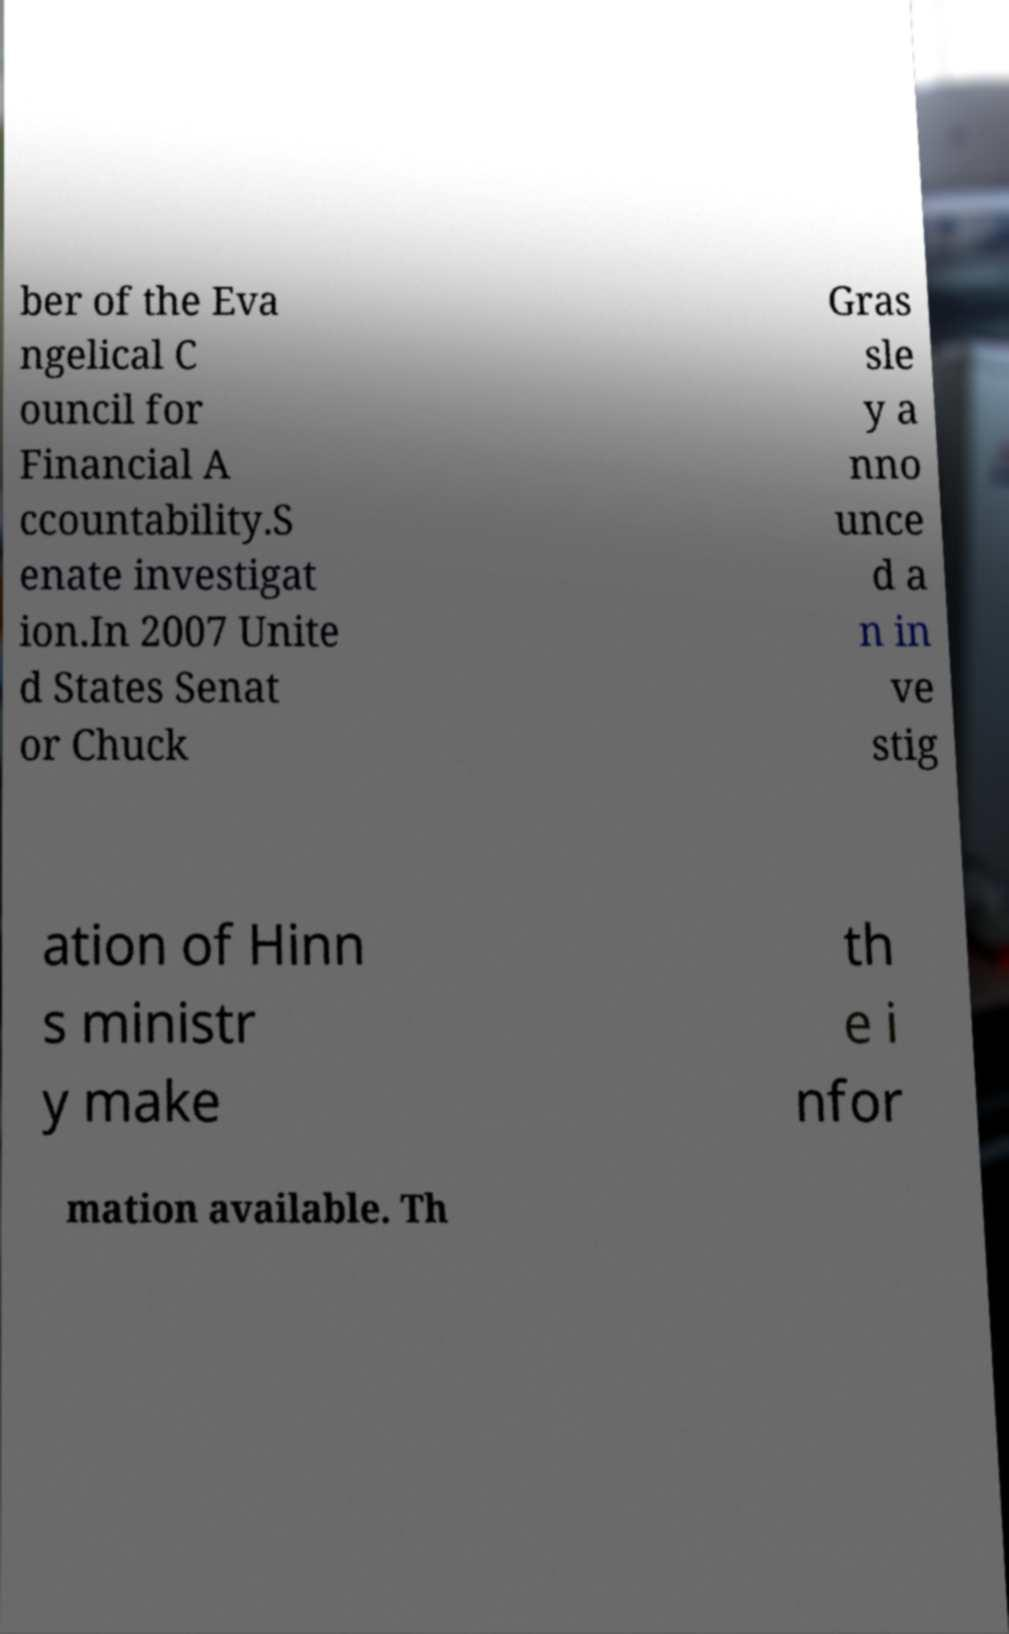What messages or text are displayed in this image? I need them in a readable, typed format. ber of the Eva ngelical C ouncil for Financial A ccountability.S enate investigat ion.In 2007 Unite d States Senat or Chuck Gras sle y a nno unce d a n in ve stig ation of Hinn s ministr y make th e i nfor mation available. Th 